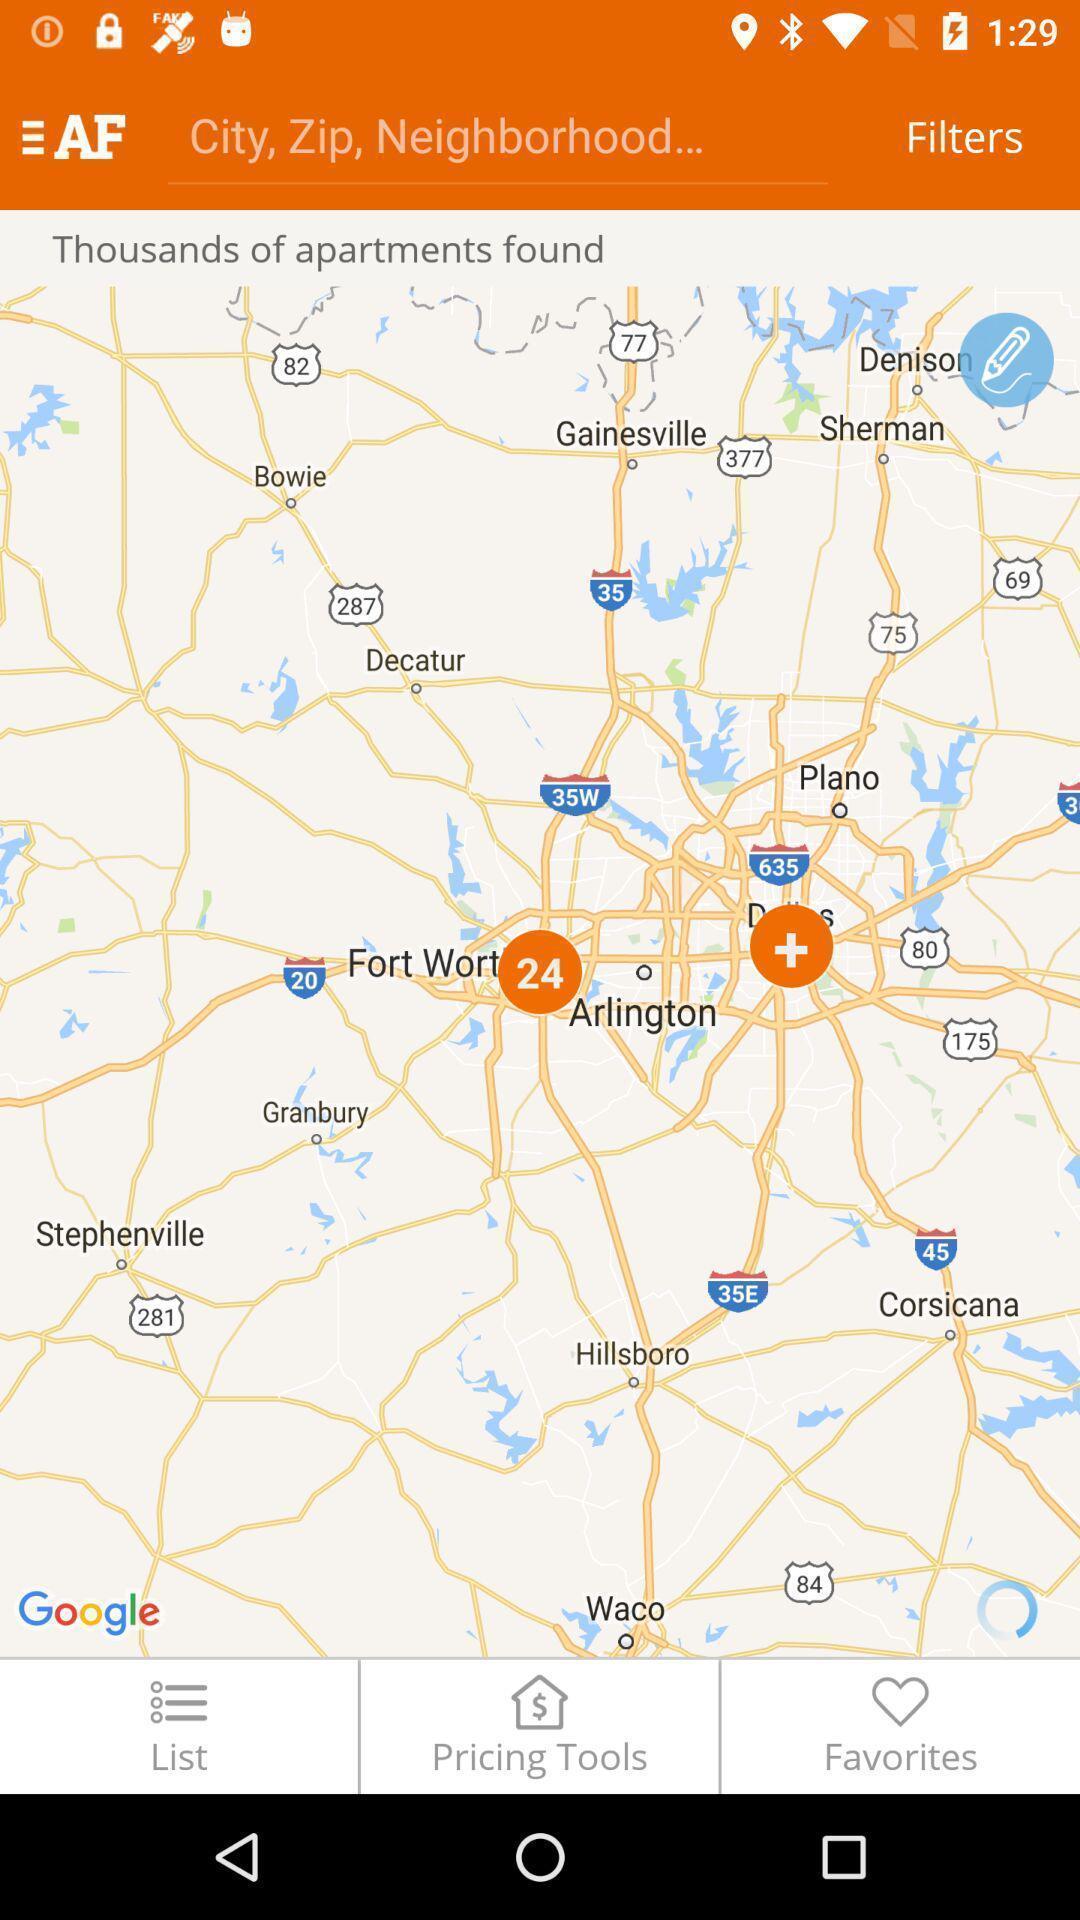Provide a description of this screenshot. Search page to find house in the property search app. 